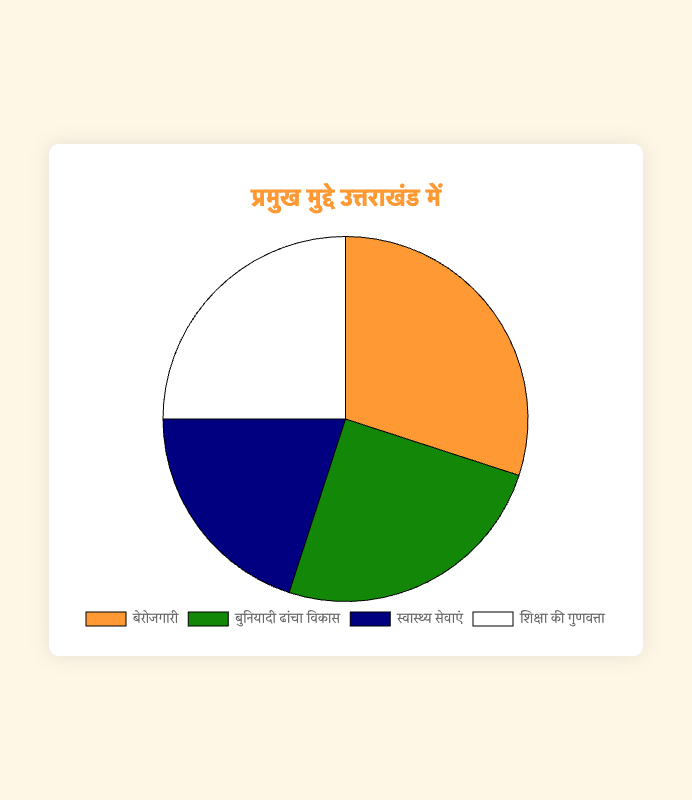Which issue is most frequently identified as a key concern by the constituents in Uttarakhand? The issue with the highest percentage is the most frequent key concern. In this case, Unemployment has the highest percentage at 30%.
Answer: Unemployment Which two issues have the same percentage of identification as key concerns? By examining the percentages, we can see that Infrastructure Development and Education Quality both have a percentage of 25%.
Answer: Infrastructure Development and Education Quality How much more frequently is Unemployment identified as a key concern compared to Healthcare Services? Subtract the percentage of Healthcare Services (20%) from the percentage of Unemployment (30%) to find the difference: 30% - 20% = 10%.
Answer: 10% What is the combined percentage of the issues related to Infrastructure Development and Education Quality? Add the percentages of both issues: 25% (Infrastructure Development) + 25% (Education Quality) = 50%.
Answer: 50% Which issue has the least percentage of identification as a key concern? The issue with the smallest percentage is the least identified key concern. Here, Healthcare Services has the smallest percentage at 20%.
Answer: Healthcare Services If you combine the percentages of Unemployment and Healthcare Services, what fraction of the total key concerns does this represent? Add the percentages of Unemployment (30%) and Healthcare Services (20%) to get 50%. This combined value represents 50% of the total. In fraction form, this is 50/100, which simplifies to 1/2.
Answer: 1/2 What is the average percentage of the four key issues identified? To find the average, add the percentages of all four issues and divide by the number of issues: (30% + 25% + 20% + 25%) / 4 = 100% / 4 = 25%.
Answer: 25% Which issue is represented by the green color in the pie chart? By referring to the configuration details, we know that the green color (‘#138808’) corresponds to Infrastructure Development.
Answer: Infrastructure Development What is the combined percentage of issues not related to Unemployment? Add the percentages of Infrastructure Development, Healthcare Services, and Education Quality: 25% + 20% + 25% = 70%.
Answer: 70% Which issues have a combined percentage that matches the percentage of Unemployment? The two issues Healthcare Services (20%) and Education Quality (25%) when combined give 45%. However, no exact match to 30% of Unemployment is found directly in the data. Therefore, it's checking carefully to look for an unlikely match.
Answer: None 